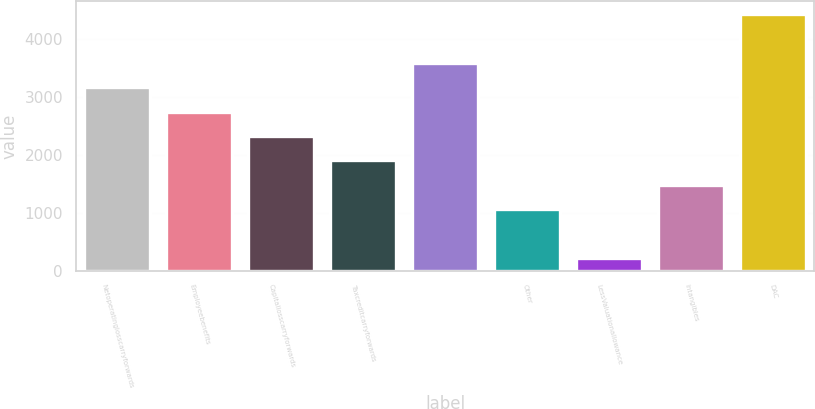Convert chart. <chart><loc_0><loc_0><loc_500><loc_500><bar_chart><fcel>Netoperatinglosscarryforwards<fcel>Employeebenefits<fcel>Capitallosscarryforwards<fcel>Taxcreditcarryforwards<fcel>Unnamed: 4<fcel>Other<fcel>LessValuationallowance<fcel>Intangibles<fcel>DAC<nl><fcel>3172.4<fcel>2750.2<fcel>2328<fcel>1905.8<fcel>3594.6<fcel>1061.4<fcel>217<fcel>1483.6<fcel>4439<nl></chart> 